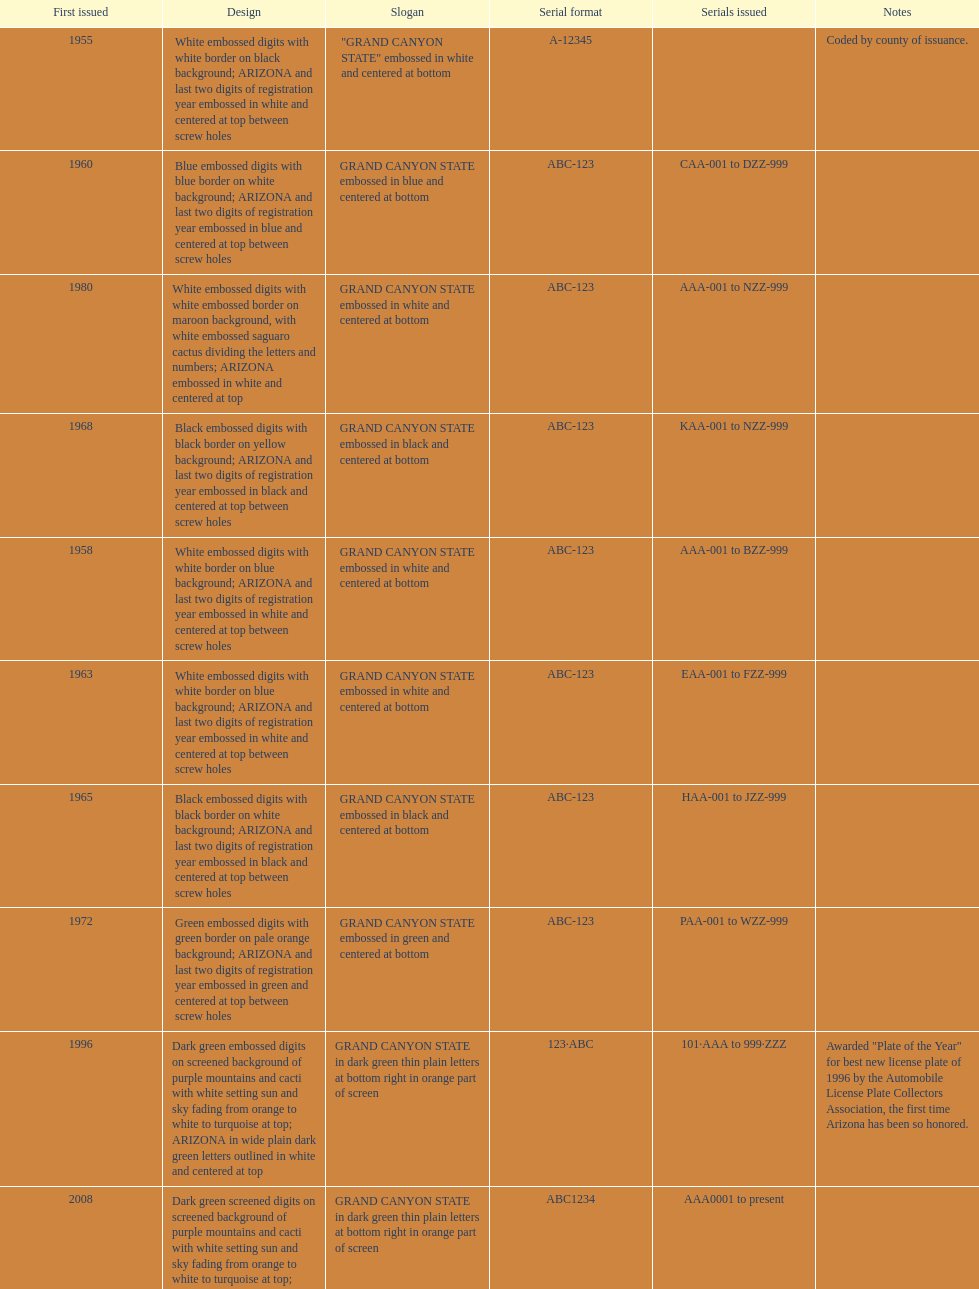Name the year of the license plate that has the largest amount of alphanumeric digits. 2008. 